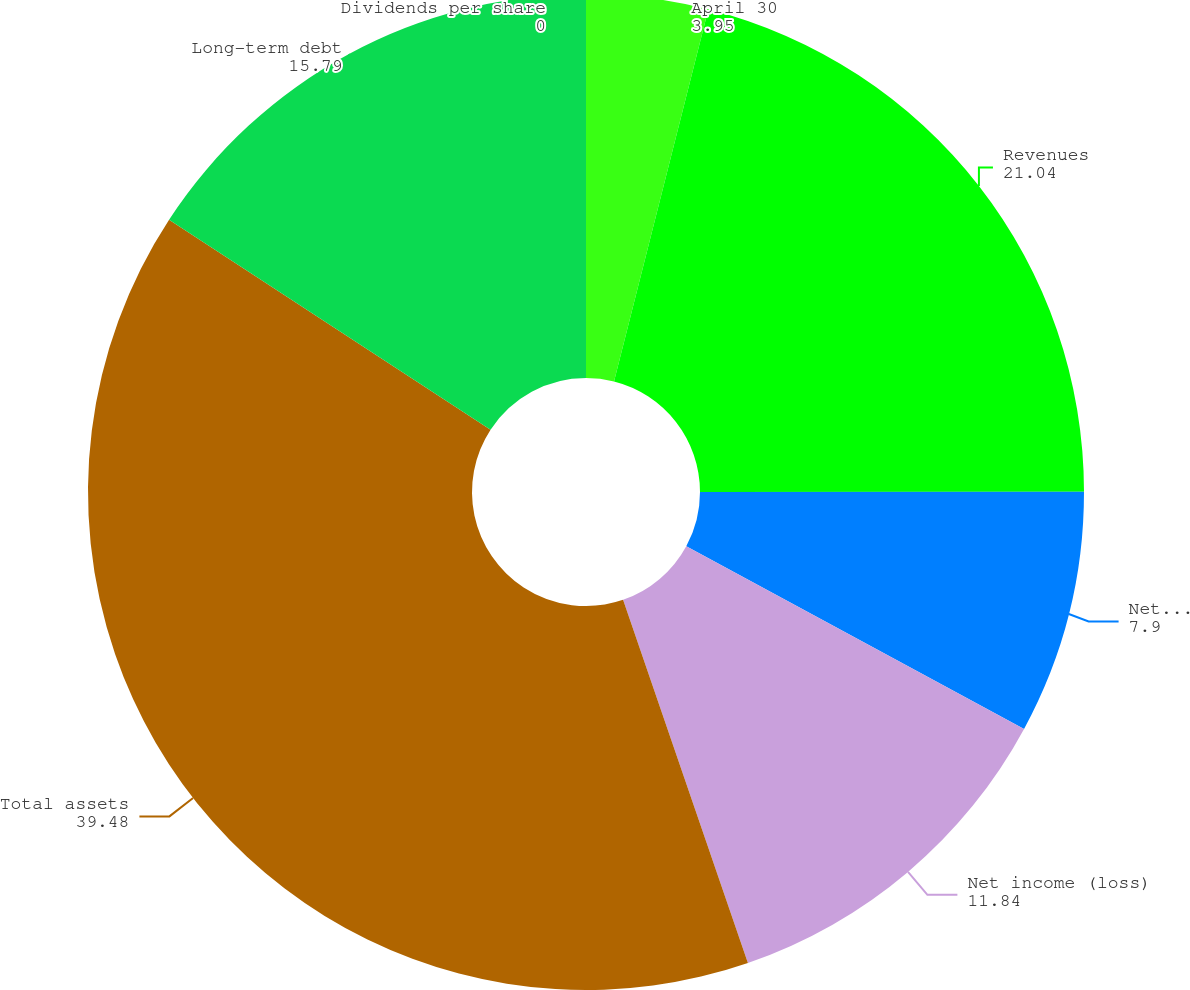Convert chart. <chart><loc_0><loc_0><loc_500><loc_500><pie_chart><fcel>April 30<fcel>Revenues<fcel>Net income before discontinued<fcel>Net income (loss)<fcel>Total assets<fcel>Long-term debt<fcel>Dividends per share<nl><fcel>3.95%<fcel>21.04%<fcel>7.9%<fcel>11.84%<fcel>39.48%<fcel>15.79%<fcel>0.0%<nl></chart> 